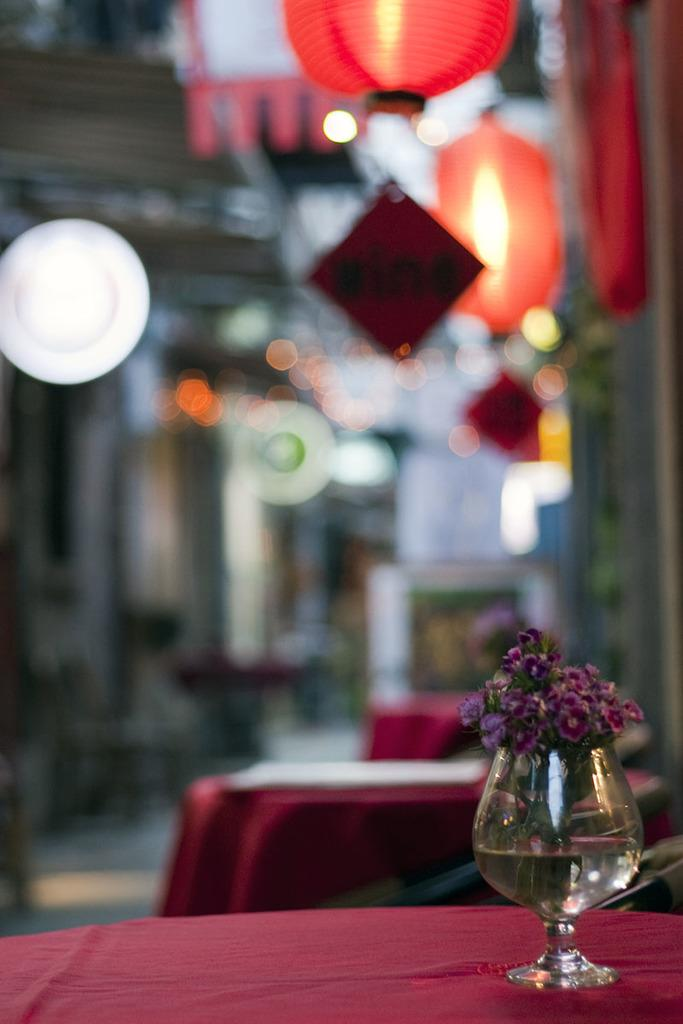What object in the image contains flowers? The glass in the image contains flowers. Where is the glass located? The glass is on a table. What type of friction can be observed between the flowers and the glass in the image? There is no observable friction between the flowers and the glass in the image. Is there a notebook present in the image? There is no notebook present in the image. 